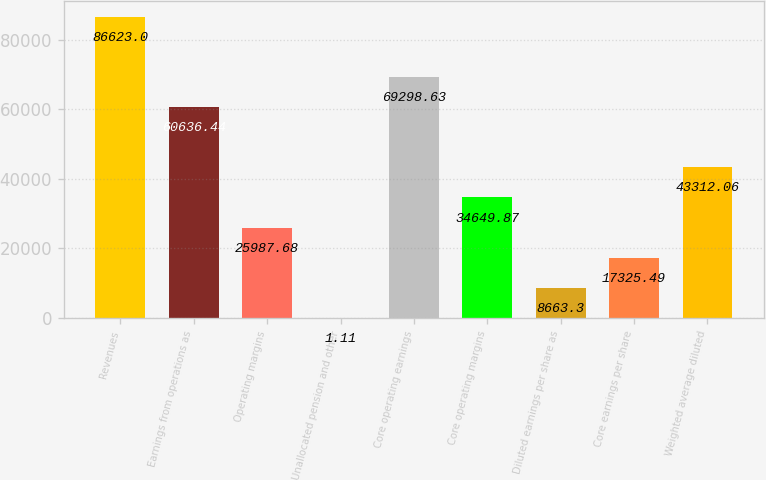Convert chart. <chart><loc_0><loc_0><loc_500><loc_500><bar_chart><fcel>Revenues<fcel>Earnings from operations as<fcel>Operating margins<fcel>Unallocated pension and other<fcel>Core operating earnings<fcel>Core operating margins<fcel>Diluted earnings per share as<fcel>Core earnings per share<fcel>Weighted average diluted<nl><fcel>86623<fcel>60636.4<fcel>25987.7<fcel>1.11<fcel>69298.6<fcel>34649.9<fcel>8663.3<fcel>17325.5<fcel>43312.1<nl></chart> 